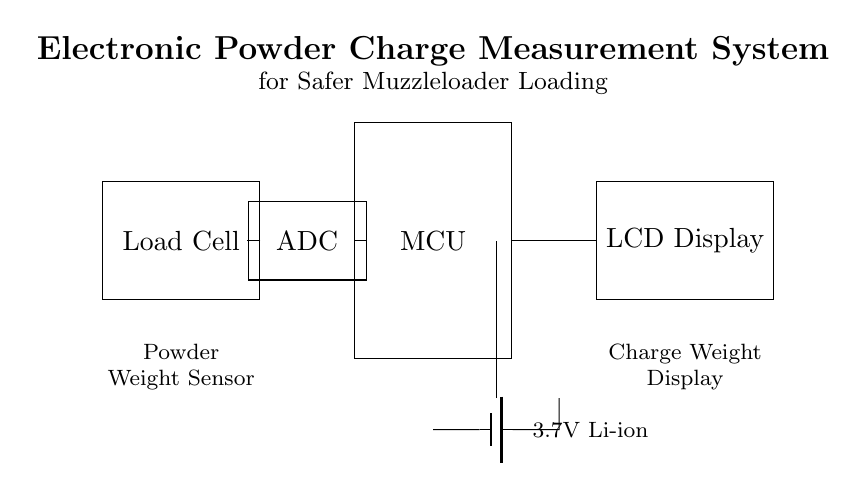What is the main function of the load cell in this circuit? The load cell functions as the powder weight sensor, measuring the weight of the powder charge being loaded.
Answer: Powder weight sensor What is the power supply voltage for this system? The battery in the circuit is specified as a 3.7V Li-ion, indicating the operating voltage for the entire system.
Answer: 3.7V Which component displays the measured powder charge? The LCD display is connected to the microcontroller, receiving processed data to show the powder charge weight.
Answer: LCD display How is the load cell connected to the ADC? The load cell provides an output signal that is directly connected to the input of the ADC, allowing it to convert the analog signal to a digital format.
Answer: Directly connected What is the role of the microcontroller in this circuit? The microcontroller processes the digital signal from the ADC and controls the output to the LCD display, enabling effective user interaction with the powder charge measurement.
Answer: Processing signal How many main components are there in the circuit? The circuit contains four main components: Load Cell, ADC, MCU, and LCD Display.
Answer: Four components What does ADC stand for? ADC stands for Analog to Digital Converter, which converts the analog signals from the load cell into a digital format for the microcontroller.
Answer: Analog to Digital Converter 